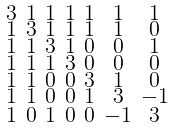Convert formula to latex. <formula><loc_0><loc_0><loc_500><loc_500>\begin{smallmatrix} 3 & 1 & 1 & 1 & 1 & 1 & 1 \\ 1 & 3 & 1 & 1 & 1 & 1 & 0 \\ 1 & 1 & 3 & 1 & 0 & 0 & 1 \\ 1 & 1 & 1 & 3 & 0 & 0 & 0 \\ 1 & 1 & 0 & 0 & 3 & 1 & 0 \\ 1 & 1 & 0 & 0 & 1 & 3 & - 1 \\ 1 & 0 & 1 & 0 & 0 & - 1 & 3 \end{smallmatrix}</formula> 